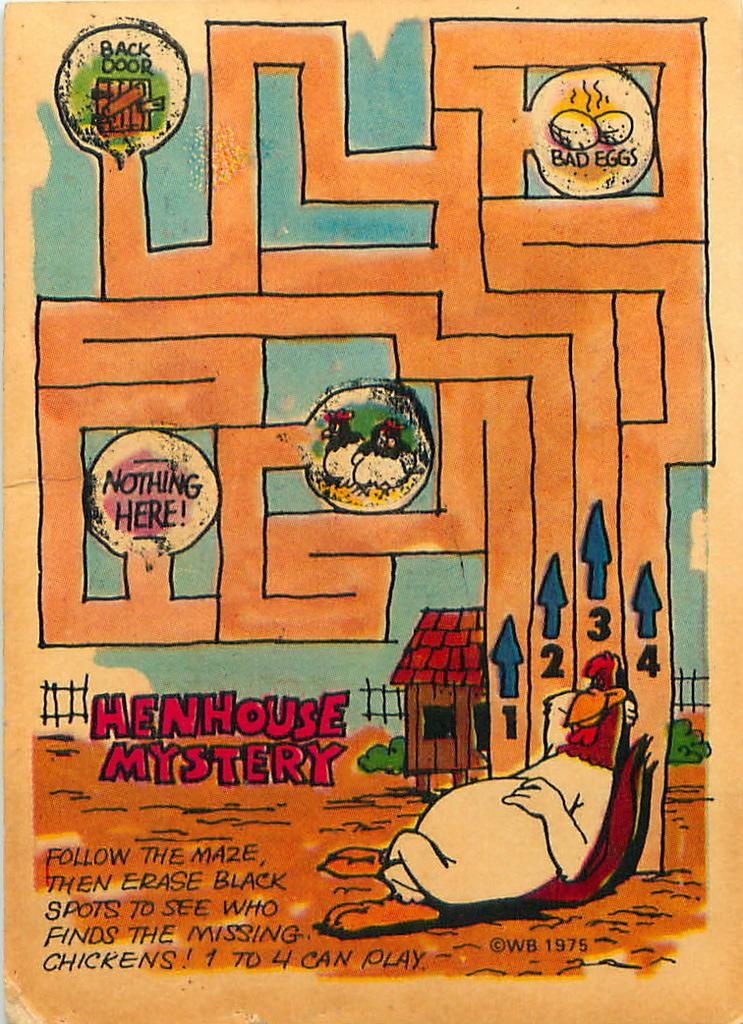Provide a one-sentence caption for the provided image. A Henhouse Mystery maze leads to a back door. 